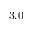<formula> <loc_0><loc_0><loc_500><loc_500>3 . 0</formula> 